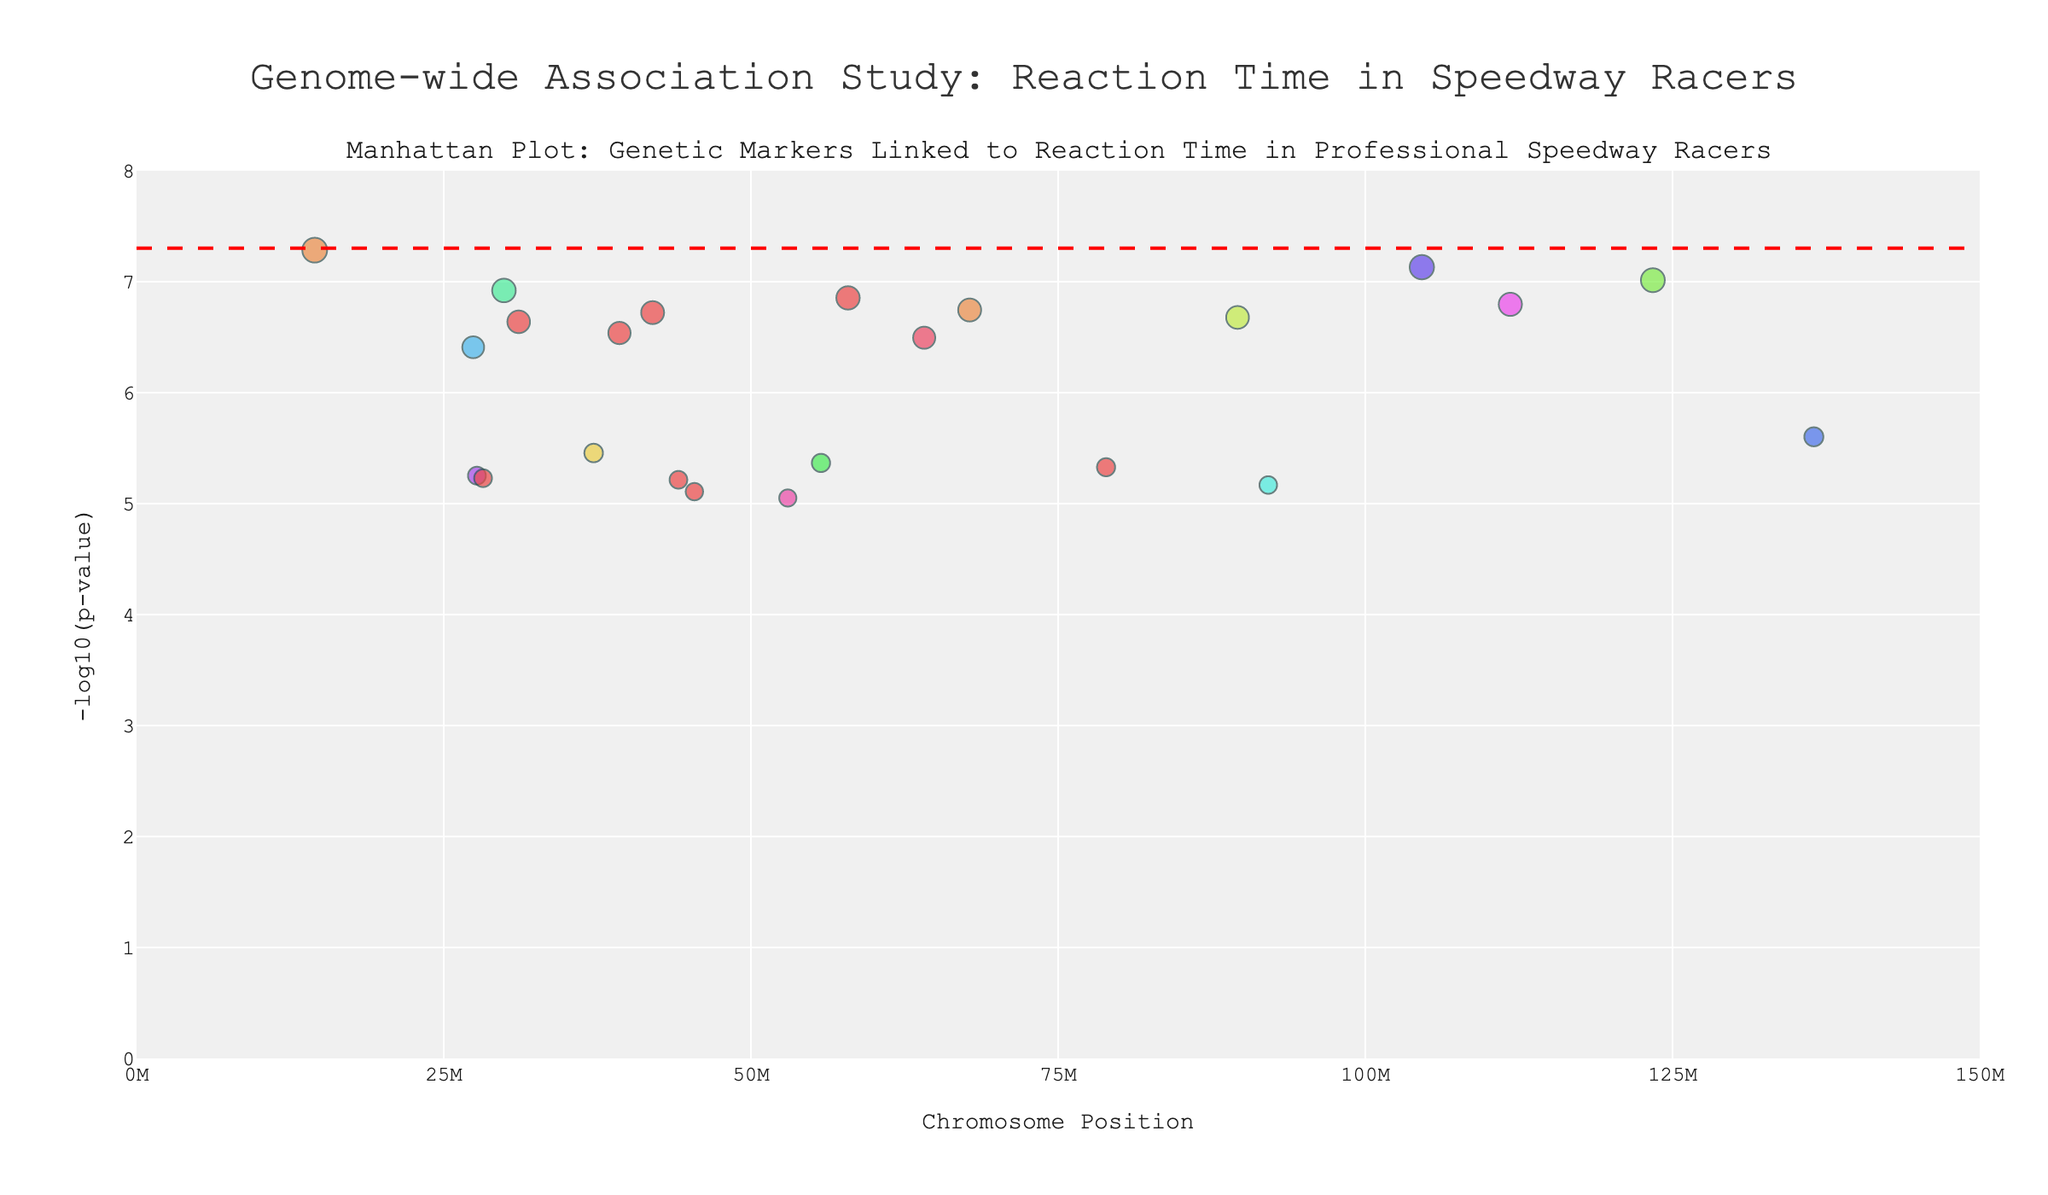What is the title of the plot? The title of the plot is typically found at the top center of the figure, providing a summary of what the plot represents. Here, it is "Genome-wide Association Study: Reaction Time in Speedway Racers."
Answer: Genome-wide Association Study: Reaction Time in Speedway Racers How many chromosomes are represented in the plot? The plot includes chromosome numbers labeled along the x-axis. By counting the distinct labels from 1 to 22, we see all 22 chromosomes are represented in the plot.
Answer: 22 Which gene has the smallest p-value? Look for the gene with the highest -log10(p-value) in the plot, as it indicates the smallest p-value. ADCY10 has the highest -log10(p-value) value.
Answer: ADCY10 What does the red dashed line in the plot represent? The red dashed line represents the genome-wide significance threshold, typically set at p = 5e-8. This threshold helps identify statistically significant genetic markers.
Answer: Genome-wide significance threshold What is the position of the gene with the second smallest p-value? The second smallest p-value corresponds to the second highest -log10(p-value) value. IL23R is the second highest, located on chromosome 1 at position 67800000.
Answer: 67800000 How many genes have a p-value less than 1e-6? Identify values in the -log10(p-value) axis greater than 6, indicating p-values less than 1e-6. There are six genes in this range: ADCY10, IL23R, EPHA3, CAMK2D, HLA-A, and CNNM2.
Answer: 6 Which chromosome has the gene with the highest -log10(p-value)? The highest -log10(p-value) corresponds to the smallest p-value, which is ADCY10. This gene is located on chromosome 1.
Answer: 1 Which gene on chromosome 10 is statistically significant? Statistically significant genes fall above the red dashed line's threshold. On chromosome 10, CNNM2 is above this threshold.
Answer: CNNM2 What is the mean position of genes on chromosome 1? The mean position is calculated by averaging the positions of genes on chromosome 1, which are 14500000 and 67800000. The mean is (14500000 + 67800000) / 2 = 41150000.
Answer: 41150000 How does the gene BDNF on chromosome 11 compare to MC4R on chromosome 18 in terms of -log10(p-value)? Compare the -log10(p-value) values of BDNF on chromosome 11 and MC4R on chromosome 18. BDNF has a -log10(p-value) of around 5.6, whereas MC4R has around 6.8. MC4R has a higher -log10(p-value) than BDNF.
Answer: MC4R has a higher -log10(p-value) 